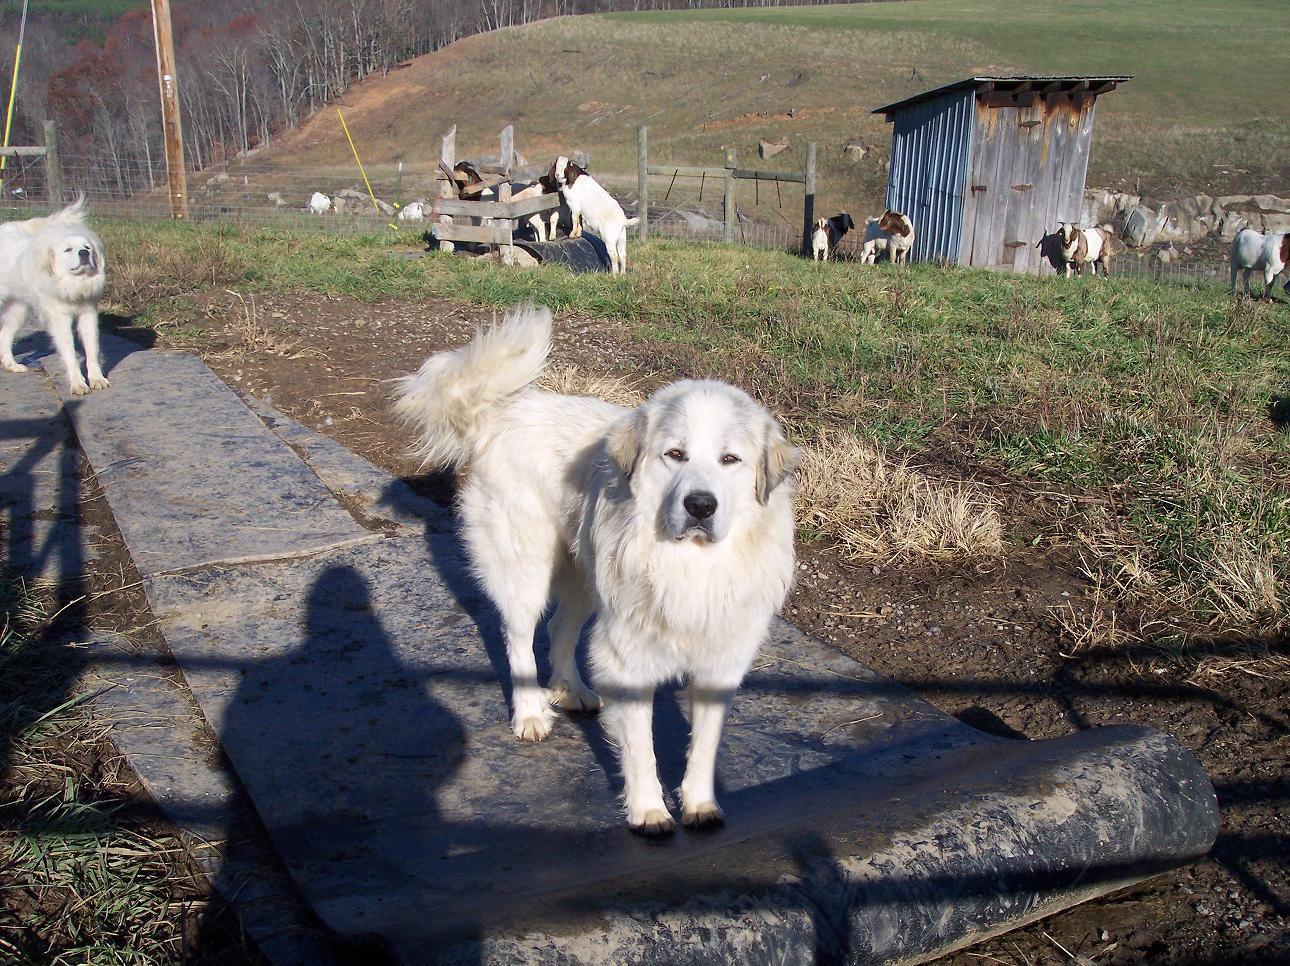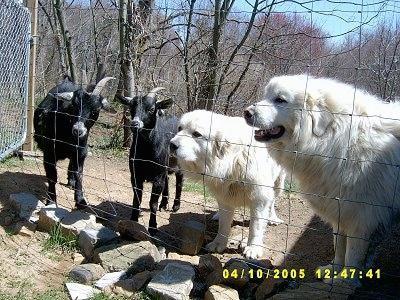The first image is the image on the left, the second image is the image on the right. Analyze the images presented: Is the assertion "At least one white dog is in a scene with goats, and a fence is present in each image." valid? Answer yes or no. Yes. The first image is the image on the left, the second image is the image on the right. For the images shown, is this caption "There is a picture of a dog and a goat together." true? Answer yes or no. Yes. 